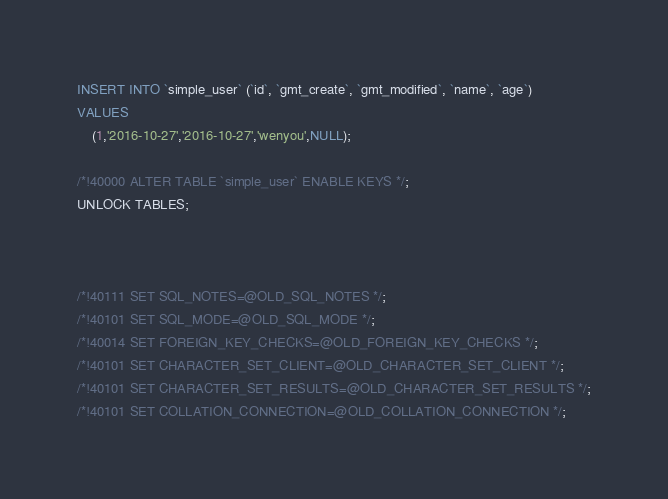Convert code to text. <code><loc_0><loc_0><loc_500><loc_500><_SQL_>
INSERT INTO `simple_user` (`id`, `gmt_create`, `gmt_modified`, `name`, `age`)
VALUES
	(1,'2016-10-27','2016-10-27','wenyou',NULL);

/*!40000 ALTER TABLE `simple_user` ENABLE KEYS */;
UNLOCK TABLES;



/*!40111 SET SQL_NOTES=@OLD_SQL_NOTES */;
/*!40101 SET SQL_MODE=@OLD_SQL_MODE */;
/*!40014 SET FOREIGN_KEY_CHECKS=@OLD_FOREIGN_KEY_CHECKS */;
/*!40101 SET CHARACTER_SET_CLIENT=@OLD_CHARACTER_SET_CLIENT */;
/*!40101 SET CHARACTER_SET_RESULTS=@OLD_CHARACTER_SET_RESULTS */;
/*!40101 SET COLLATION_CONNECTION=@OLD_COLLATION_CONNECTION */;
</code> 